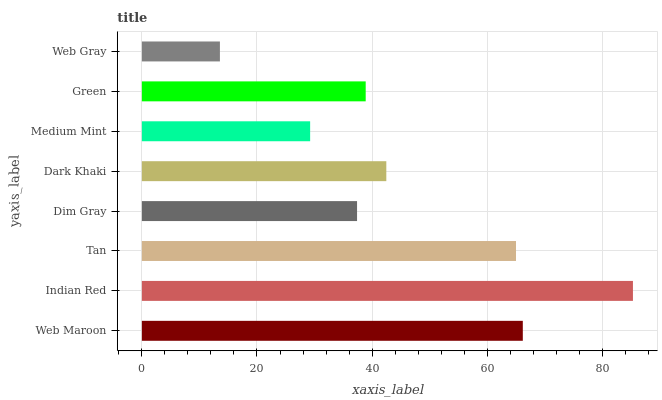Is Web Gray the minimum?
Answer yes or no. Yes. Is Indian Red the maximum?
Answer yes or no. Yes. Is Tan the minimum?
Answer yes or no. No. Is Tan the maximum?
Answer yes or no. No. Is Indian Red greater than Tan?
Answer yes or no. Yes. Is Tan less than Indian Red?
Answer yes or no. Yes. Is Tan greater than Indian Red?
Answer yes or no. No. Is Indian Red less than Tan?
Answer yes or no. No. Is Dark Khaki the high median?
Answer yes or no. Yes. Is Green the low median?
Answer yes or no. Yes. Is Green the high median?
Answer yes or no. No. Is Web Gray the low median?
Answer yes or no. No. 